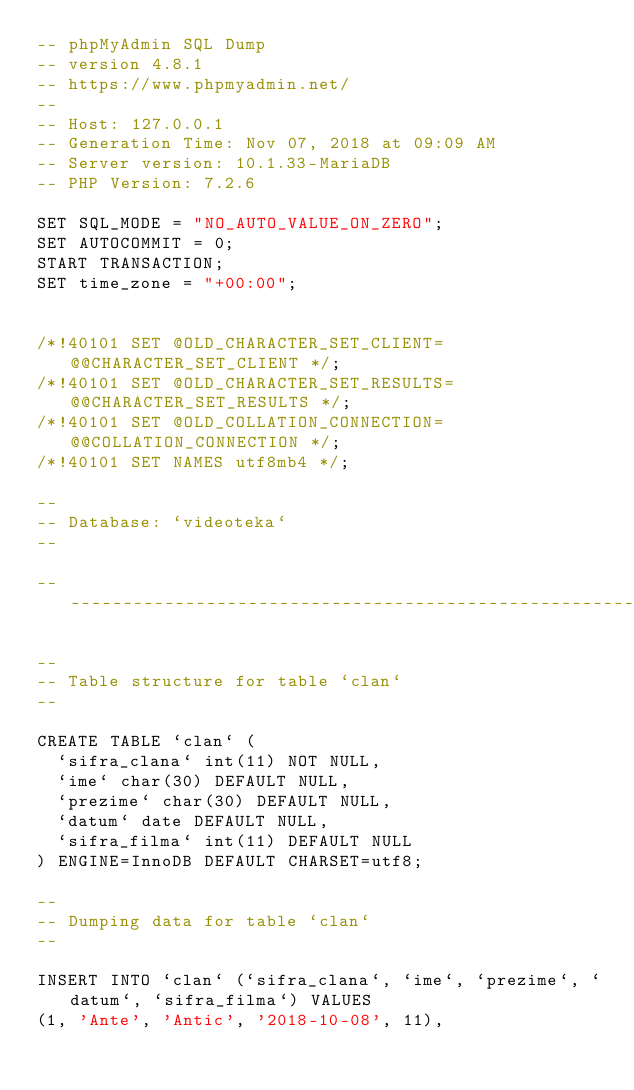<code> <loc_0><loc_0><loc_500><loc_500><_SQL_>-- phpMyAdmin SQL Dump
-- version 4.8.1
-- https://www.phpmyadmin.net/
--
-- Host: 127.0.0.1
-- Generation Time: Nov 07, 2018 at 09:09 AM
-- Server version: 10.1.33-MariaDB
-- PHP Version: 7.2.6

SET SQL_MODE = "NO_AUTO_VALUE_ON_ZERO";
SET AUTOCOMMIT = 0;
START TRANSACTION;
SET time_zone = "+00:00";


/*!40101 SET @OLD_CHARACTER_SET_CLIENT=@@CHARACTER_SET_CLIENT */;
/*!40101 SET @OLD_CHARACTER_SET_RESULTS=@@CHARACTER_SET_RESULTS */;
/*!40101 SET @OLD_COLLATION_CONNECTION=@@COLLATION_CONNECTION */;
/*!40101 SET NAMES utf8mb4 */;

--
-- Database: `videoteka`
--

-- --------------------------------------------------------

--
-- Table structure for table `clan`
--

CREATE TABLE `clan` (
  `sifra_clana` int(11) NOT NULL,
  `ime` char(30) DEFAULT NULL,
  `prezime` char(30) DEFAULT NULL,
  `datum` date DEFAULT NULL,
  `sifra_filma` int(11) DEFAULT NULL
) ENGINE=InnoDB DEFAULT CHARSET=utf8;

--
-- Dumping data for table `clan`
--

INSERT INTO `clan` (`sifra_clana`, `ime`, `prezime`, `datum`, `sifra_filma`) VALUES
(1, 'Ante', 'Antic', '2018-10-08', 11),</code> 